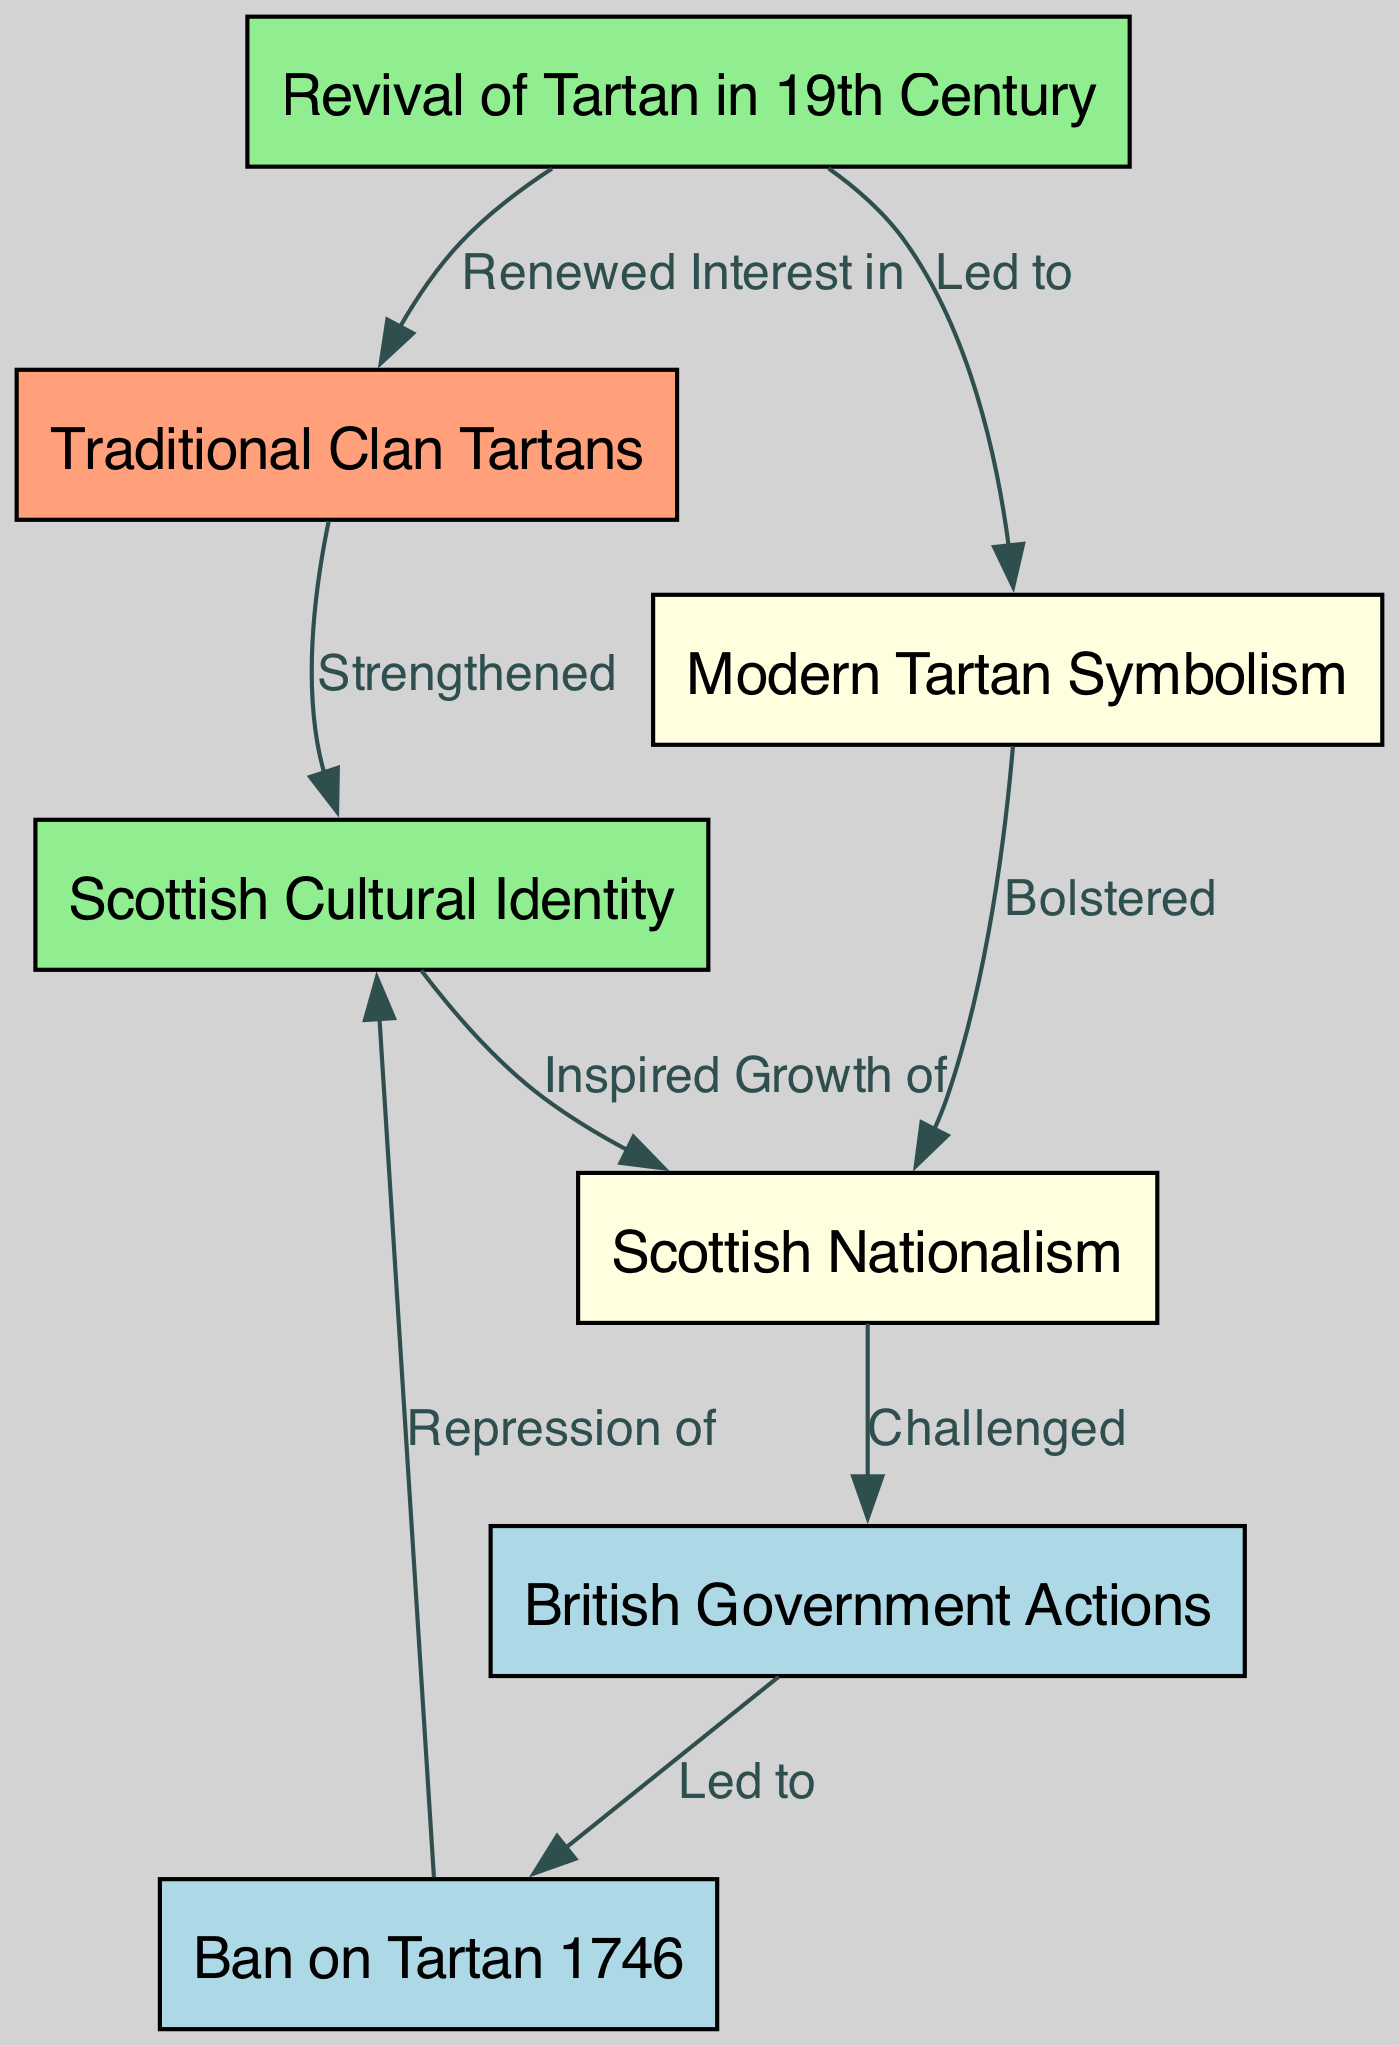What nodes are in the diagram? The nodes in the diagram are Traditional Clan Tartans, British Government Actions, Ban on Tartan 1746, Revival of Tartan in 19th Century, Scottish Cultural Identity, Scottish Nationalism, and Modern Tartan Symbolism. These are explicitly listed as the elements of the diagram which represent various factors related to tartan patterns in Scottish identity.
Answer: Traditional Clan Tartans, British Government Actions, Ban on Tartan 1746, Revival of Tartan in 19th Century, Scottish Cultural Identity, Scottish Nationalism, Modern Tartan Symbolism How many edges are in the diagram? To find the total number of edges, count each relationship drawn between the nodes in the graph. In this case, there are 8 edges that connect the different nodes, indicating a variety of interactions and influences among the concepts presented.
Answer: 8 What did the Ban on Tartan 1746 lead to? The Ban on Tartan 1746 is shown to lead to the repression of Scottish cultural identity. This is indicated by the direct cause-and-effect relationship moving from the ban to the repression, signifying a negative impact on cultural expression.
Answer: Repression of Which node is strengthened by Traditional Clan Tartans? The Traditional Clan Tartans directly strengthen the Scottish Cultural Identity according to the diagram. This relationship indicates that clan tartans play a pivotal role in enhancing and reinforcing the cultural identity of Scotland.
Answer: Scottish Cultural Identity What inspired the growth of Scottish Nationalism? According to the diagram, the Scottish Cultural Identity inspired the growth of Scottish Nationalism. This demonstrates how a strong sense of cultural identity can lead to an increase in national pride and nationalist sentiment.
Answer: Scottish Cultural Identity How did Modern Tartan Symbolism affect Scottish Nationalism? The diagram indicates that Modern Tartan Symbolism bolstered the Scottish Nationalism. This suggests that contemporary interpretations of tartan, as symbols of identity and pride, have a reinforcing effect on nationalist movements and sentiments within Scotland.
Answer: Bolstered What was the effect of British Government Actions? The British Government Actions led to the Ban on Tartan 1746, which is a significant step showing the repressive nature of governmental authority over cultural practices in Scotland, leading to further ramifications outlined in the diagram.
Answer: Ban on Tartan 1746 What is the connection between the Revival of Tartan in the 19th Century and Modern Tartan Symbolism? The Revival of Tartan in the 19th Century led to Modern Tartan Symbolism, indicating that the renewed interest in tartans during the 1800s resulted in new meanings and expressions of tartan in contemporary culture, highlighting its evolution.
Answer: Led to 